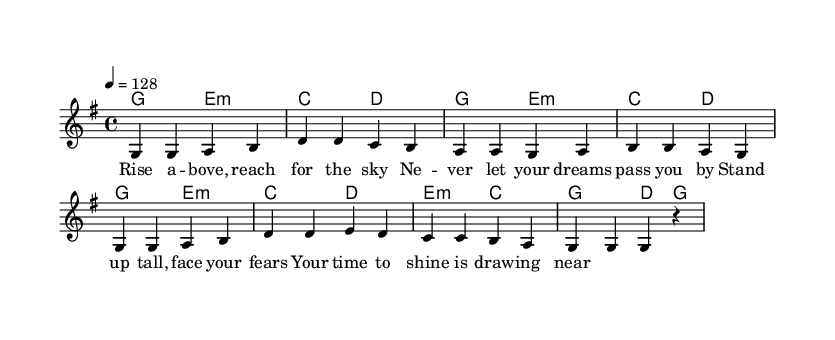What is the time signature of this music? The time signature is indicated at the beginning of the score, showing a 4 over 4, which means there are four beats in each measure.
Answer: 4/4 What is the key signature of this music? The key signature shows one sharp, which corresponds to the key of G major. This can be determined by identifying the sharp noted on the staff, which is F#.
Answer: G major What is the tempo marking for this music? The tempo marking indicates the speed of the piece, which is set to 128 beats per minute. This is noted explicitly in the tempo section.
Answer: 128 How many measures are there in the melody? By counting the phrases in the melody section, we can see that there are a total of 8 measures present. Each measure is separated by bar lines.
Answer: 8 What is the overall theme of the lyrics? The lyrics convey an inspirational message about pursuing dreams and overcoming challenges, highlighted by phrases that encourage standing tall and facing fears.
Answer: Inspiration Which instrument is primarily featured in the score? The score indicates a voice part labeled "lead," which implies that the primary instrument for melody is the human voice.
Answer: Voice 